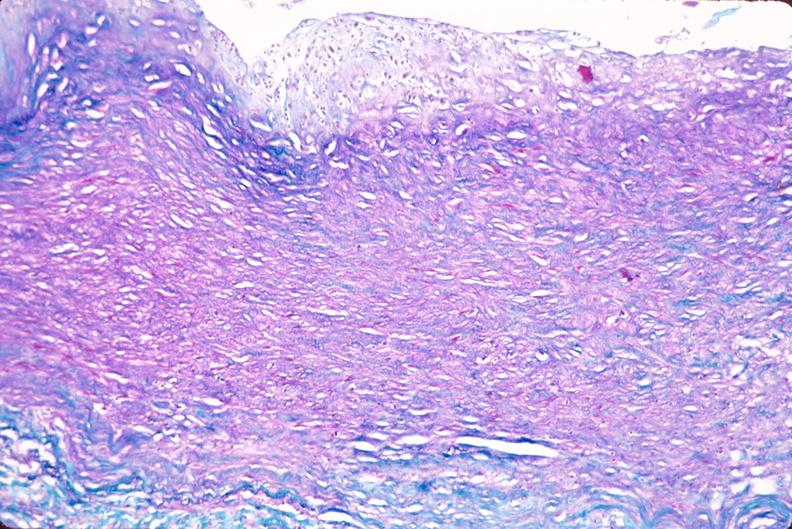what is present?
Answer the question using a single word or phrase. Cardiovascular 